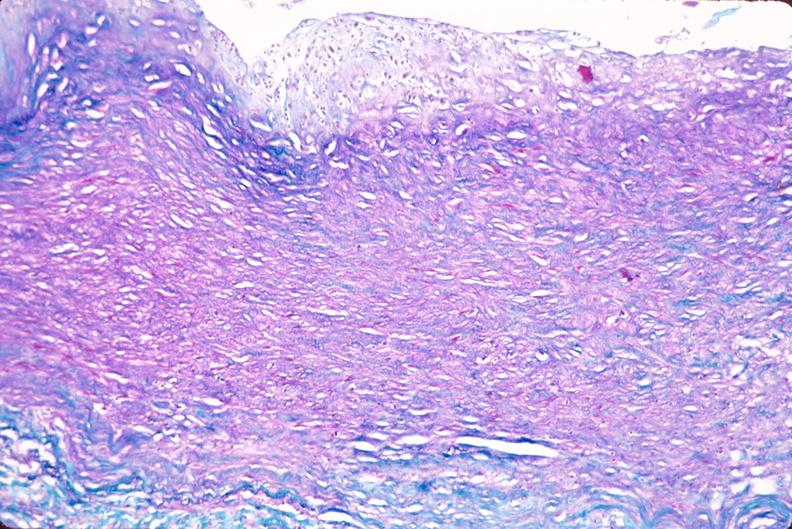what is present?
Answer the question using a single word or phrase. Cardiovascular 